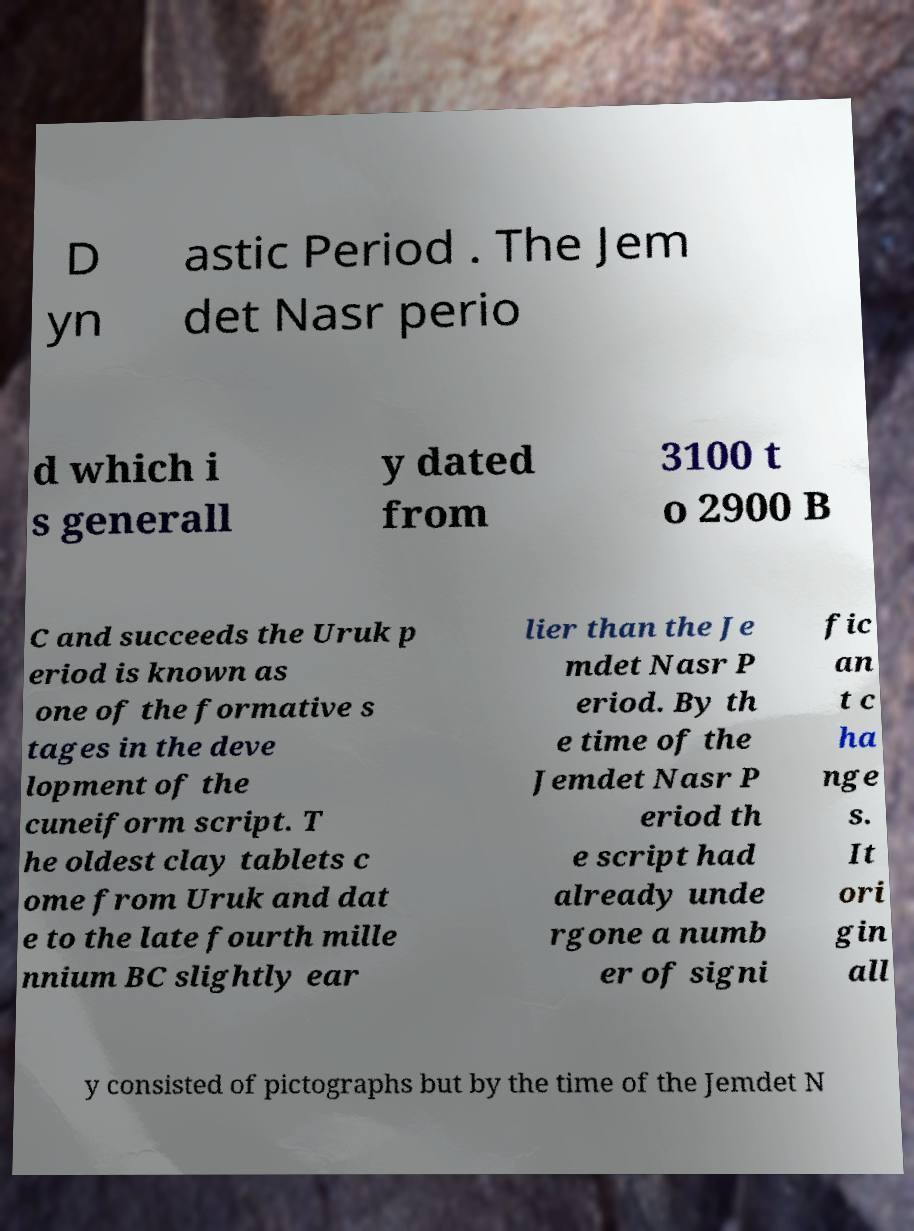Please identify and transcribe the text found in this image. D yn astic Period . The Jem det Nasr perio d which i s generall y dated from 3100 t o 2900 B C and succeeds the Uruk p eriod is known as one of the formative s tages in the deve lopment of the cuneiform script. T he oldest clay tablets c ome from Uruk and dat e to the late fourth mille nnium BC slightly ear lier than the Je mdet Nasr P eriod. By th e time of the Jemdet Nasr P eriod th e script had already unde rgone a numb er of signi fic an t c ha nge s. It ori gin all y consisted of pictographs but by the time of the Jemdet N 